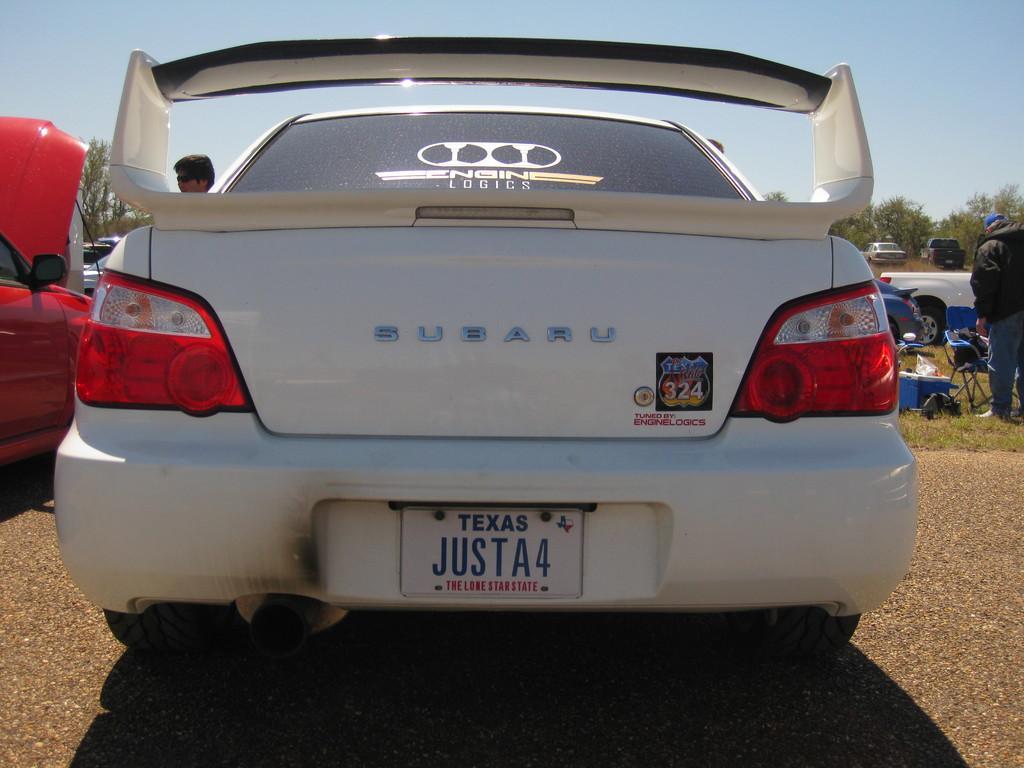Describe this image in one or two sentences. In this image in the front there are cars. In the background there are persons and there is grass on the ground and there are trees and cars and there are objects which are blue and black in colour. 